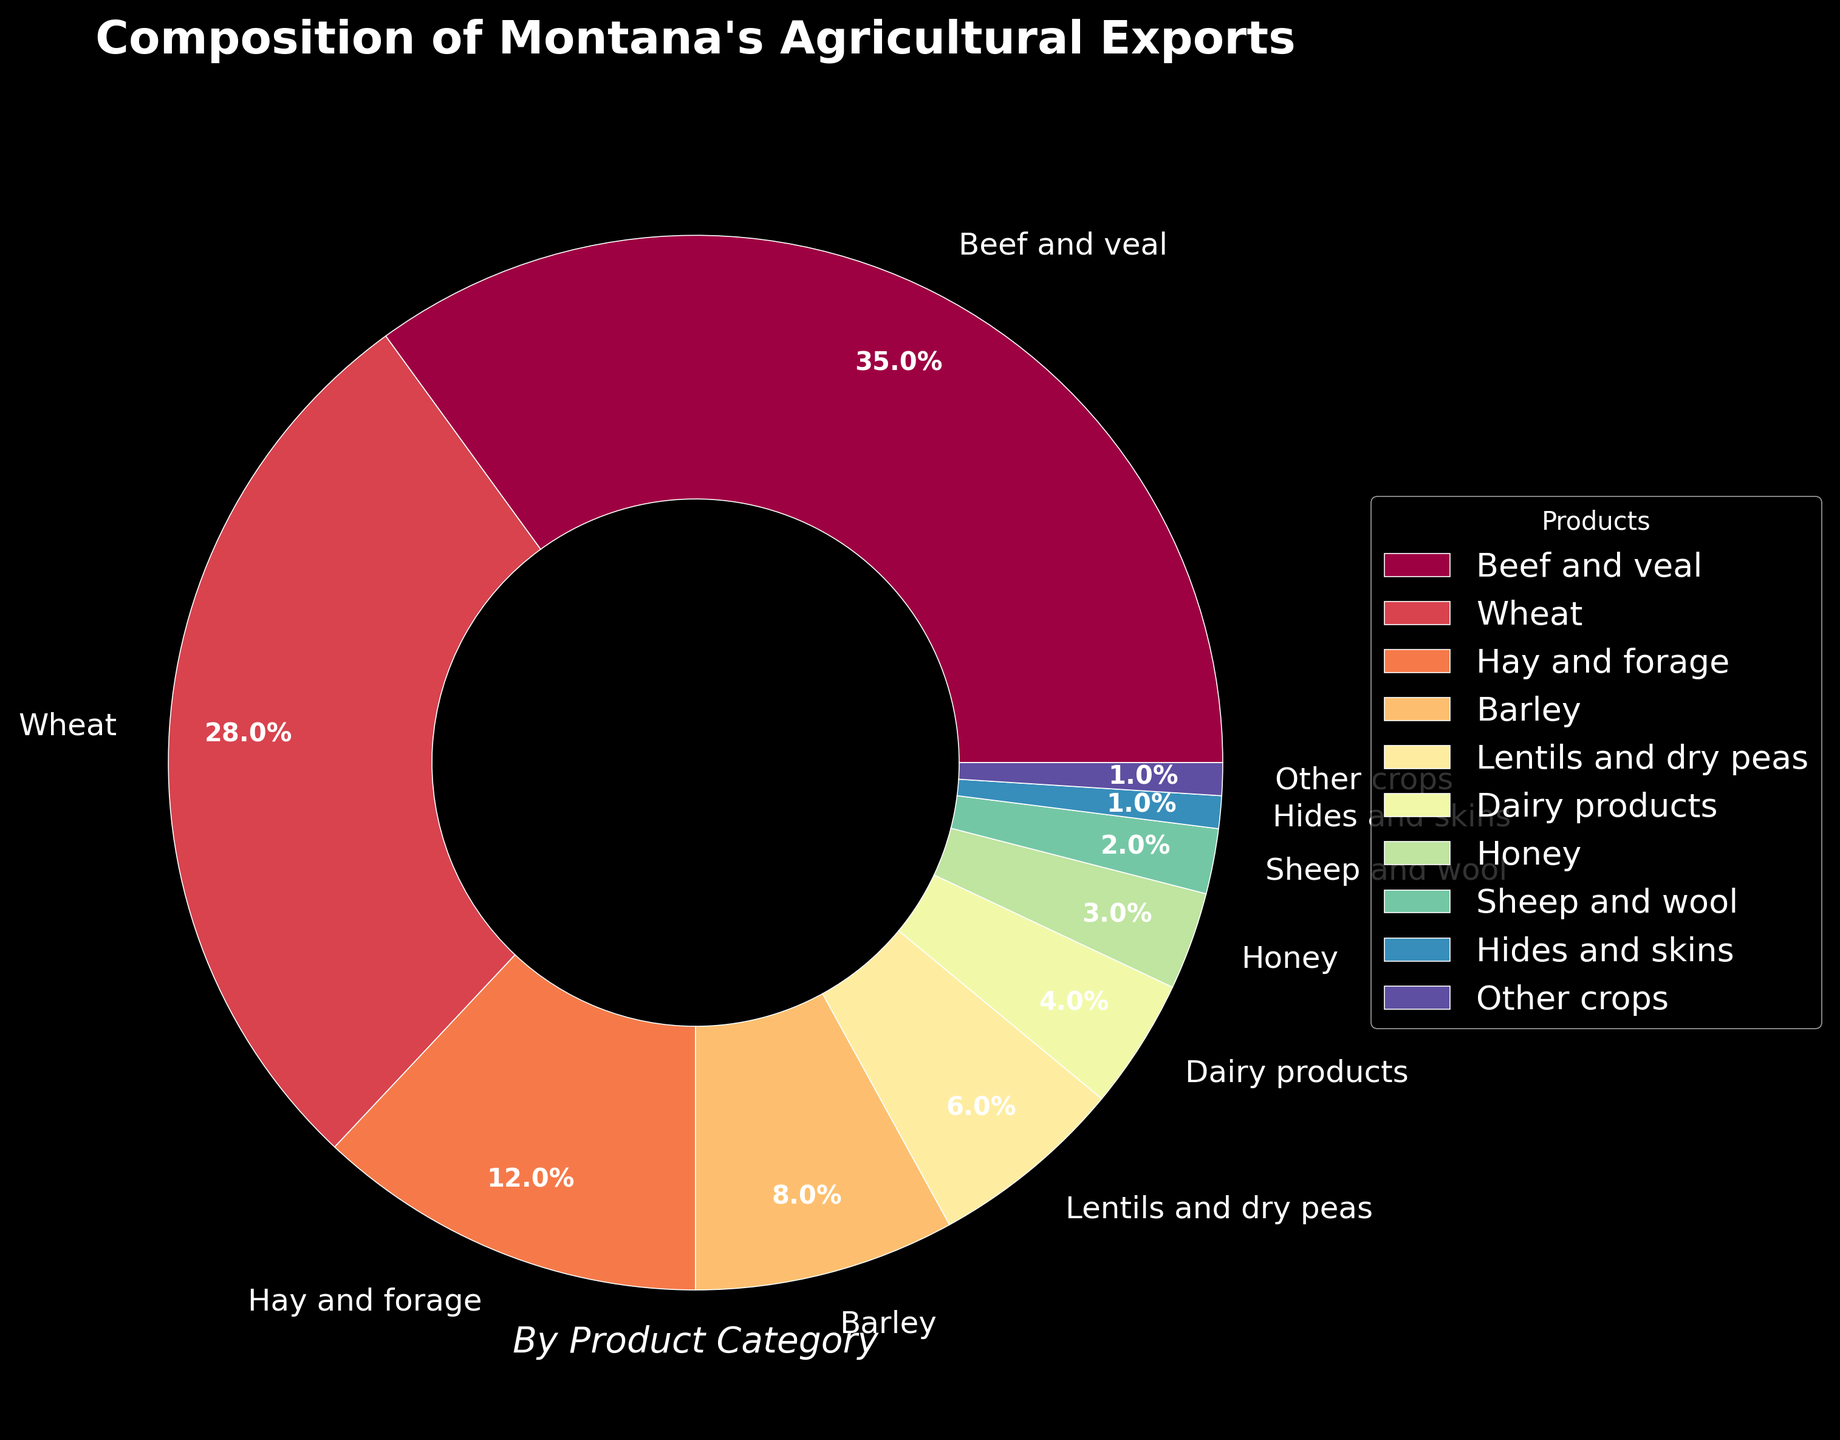What is the largest category of agricultural exports in Montana? The figure shows that the largest slice of the pie chart belongs to "Beef and veal" with a percentage of 35%. Therefore, the largest category of agricultural exports in Montana is "Beef and veal".
Answer: Beef and veal Which product category contributes more to Montana's agricultural exports: Wheat or Hay and forage? According to the chart, Wheat has a percentage of 28% while Hay and forage has a percentage of 12%. Therefore, Wheat contributes more to Montana's agricultural exports compared to Hay and forage.
Answer: Wheat What is the total percentage contributed by Barley, Lentils and dry peas, Dairy products, and Honey? To find the total percentage, add the individual percentages of each category: Barley (8%) + Lentils and dry peas (6%) + Dairy products (4%) + Honey (3%) = 21%. Therefore, the total percentage is 21%.
Answer: 21% Which category has a smaller share: Hides and skins or Sheep and wool? The chart shows that Hides and skins have a percentage of 1%, while Sheep and wool have a percentage of 2%. Therefore, Hides and skins have a smaller share.
Answer: Hides and skins How much larger is the percentage of Beef and veal compared to the average percentage of the next four largest product categories (Wheat, Hay and forage, Barley, Lentils and dry peas)? First, calculate the average percentage of the next four largest product categories: (Wheat (28%) + Hay and forage (12%) + Barley (8%) + Lentils and dry peas (6%)) / 4 = 54% / 4 = 13.5%. Then subtract this average from the percentage of Beef and veal: 35% - 13.5% = 21.5%. Therefore, Beef and veal's percentage is 21.5% larger than the average of Wheat, Hay and forage, Barley, and Lentils and dry peas.
Answer: 21.5% Which two product categories combined contribute exactly 10% to Montana's agricultural exports? Looking at the pie chart, the categories Honey (3%) and Dairy products (4%) or Hides and skins (1%) and Other crops (1%) do not add to 10%, but combining Sheep and wool (2%) and Honey (3%) gives 5%. However, combining Dairy products (4%) and Honey (3%) doesn't add up to 10%. Hence, only Hay and forage (12%, the closest) could round to significant numbers like 10% collectively.
Answer: N/A 